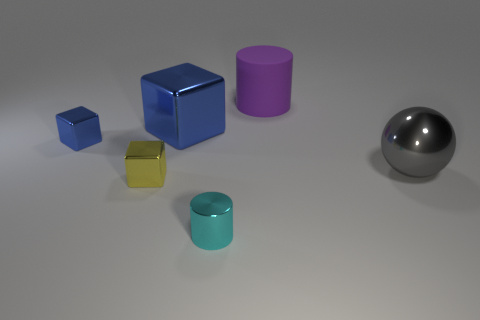What is the size of the cube that is in front of the small metallic object that is behind the shiny thing on the right side of the tiny cyan thing?
Your response must be concise. Small. There is a blue thing that is in front of the big blue block; what size is it?
Ensure brevity in your answer.  Small. What number of cyan things are the same size as the yellow metallic cube?
Ensure brevity in your answer.  1. Does the cylinder in front of the yellow shiny thing have the same size as the thing that is right of the purple object?
Offer a terse response. No. Is the number of small yellow cubes that are behind the cyan metallic cylinder greater than the number of big gray metallic spheres that are in front of the yellow shiny block?
Keep it short and to the point. Yes. How many cyan metal things have the same shape as the large matte object?
Your answer should be compact. 1. What is the material of the purple thing that is the same size as the gray metal object?
Offer a terse response. Rubber. Are there any purple cylinders that have the same material as the small blue object?
Your response must be concise. No. Is the number of big purple rubber objects that are in front of the tiny yellow object less than the number of large blue cylinders?
Keep it short and to the point. No. There is a cylinder in front of the large object on the left side of the cyan thing; what is it made of?
Provide a succinct answer. Metal. 